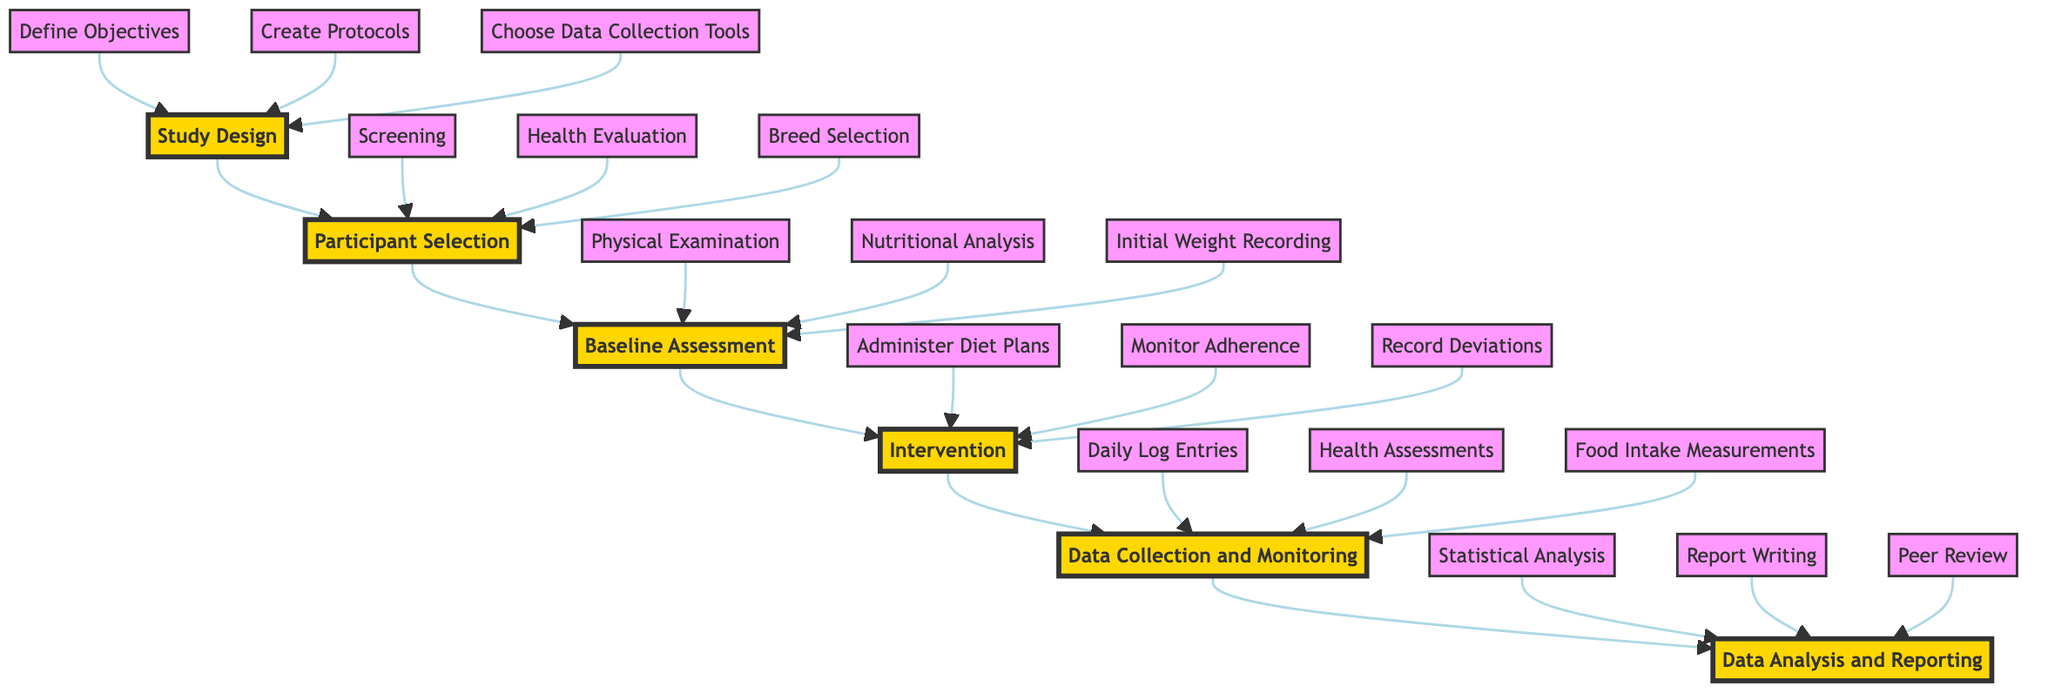What is the final step in the feeding trial process? The flow chart indicates that after data collection and monitoring, the final step is data analysis and reporting.
Answer: Data Analysis and Reporting How many main steps are in the flow chart? Counting the nodes in the flow chart, there are six main steps: Study Design, Participant Selection, Baseline Assessment, Intervention, Data Collection and Monitoring, and Data Analysis and Reporting.
Answer: 6 Which step follows the Baseline Assessment? In the flow chart, the step that immediately follows Baseline Assessment is Intervention.
Answer: Intervention What is the first task under Study Design? Under Study Design, the first task listed is to define objectives, which sets the foundation for the entire study.
Answer: Define Objectives What are the three key steps in Data Collection and Monitoring? The diagram lists the key steps as Daily Log Entries, Health Assessments, and Food Intake Measurements, which are all crucial for thorough data collection.
Answer: Daily Log Entries, Health Assessments, Food Intake Measurements Which step includes monitoring adherence? The Intervention step specifically includes monitoring adherence as one of its key responsibilities during the feeding trial.
Answer: Intervention Name one of the tasks related to participant selection. The tasks related to participant selection include Screening, Health Evaluation, and Breed Selection; any of these could be a valid answer.
Answer: Screening How does the flow of steps progress in the diagram? The flow of steps progresses from bottom to top, illustrating a sequential order starting from Study Design and culminating in Data Analysis and Reporting.
Answer: Bottom to top What is the primary purpose of the Data Analysis and Reporting step? The primary purpose is to evaluate all collected data, perform statistical analysis, and prepare research findings for publication or further study.
Answer: Evaluate data and prepare findings 